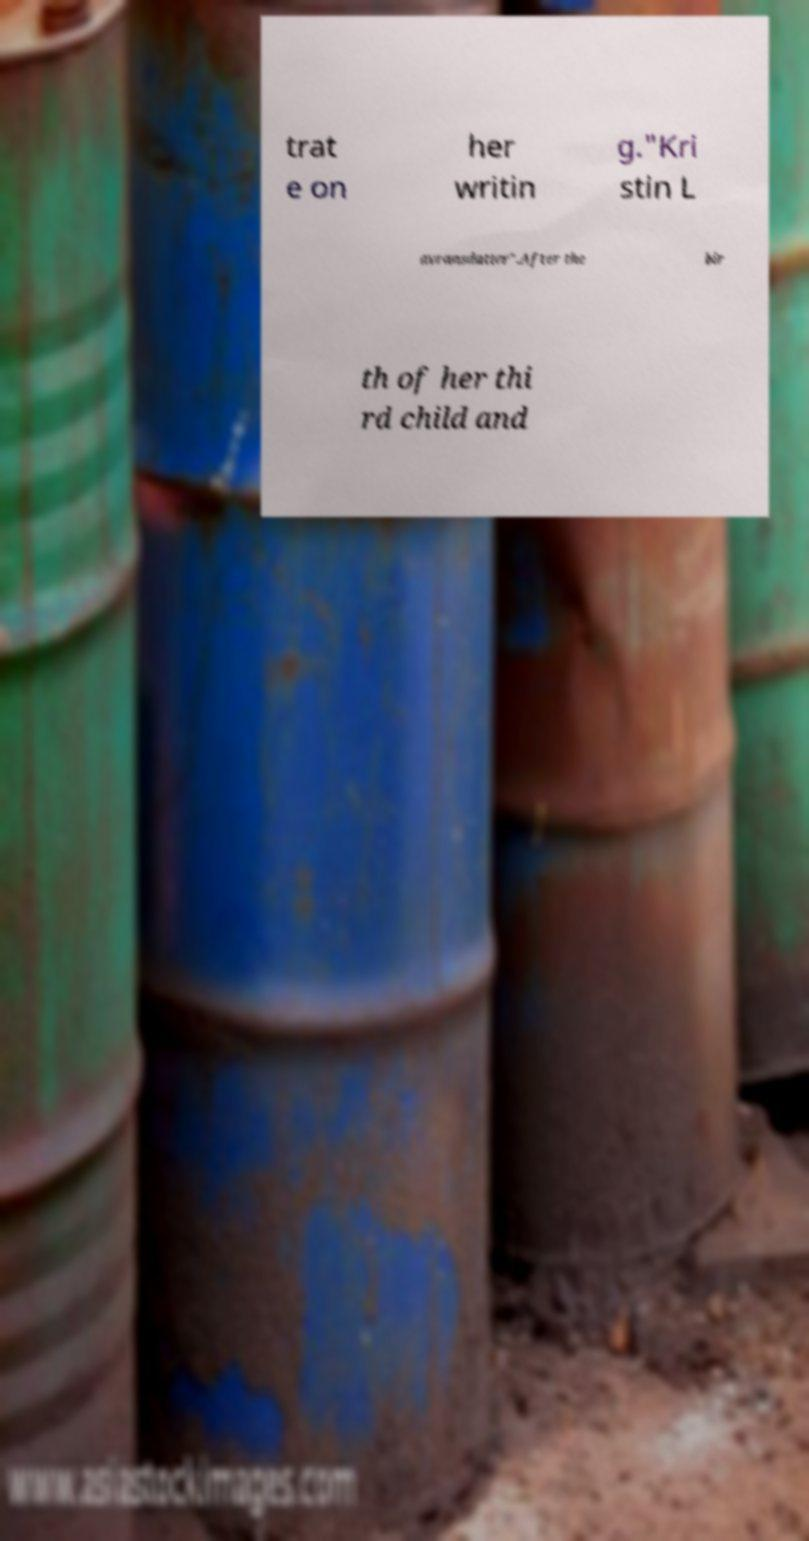What messages or text are displayed in this image? I need them in a readable, typed format. trat e on her writin g."Kri stin L avransdatter".After the bir th of her thi rd child and 